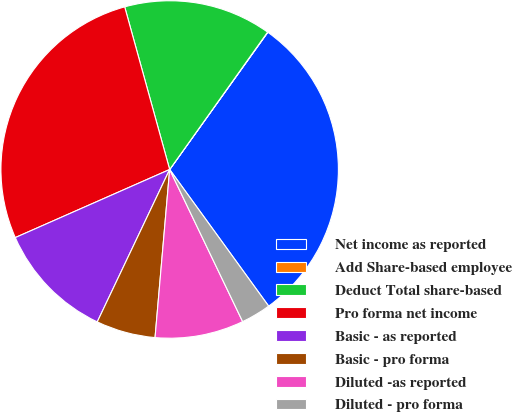<chart> <loc_0><loc_0><loc_500><loc_500><pie_chart><fcel>Net income as reported<fcel>Add Share-based employee<fcel>Deduct Total share-based<fcel>Pro forma net income<fcel>Basic - as reported<fcel>Basic - pro forma<fcel>Diluted -as reported<fcel>Diluted - pro forma<nl><fcel>30.14%<fcel>0.03%<fcel>14.15%<fcel>27.32%<fcel>11.33%<fcel>5.68%<fcel>8.5%<fcel>2.86%<nl></chart> 